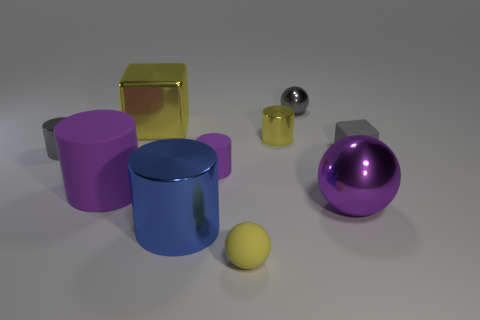Subtract all green spheres. How many purple cylinders are left? 2 Subtract all yellow spheres. How many spheres are left? 2 Subtract all balls. How many objects are left? 7 Subtract all yellow cylinders. How many cylinders are left? 4 Subtract 0 cyan cubes. How many objects are left? 10 Subtract 2 cylinders. How many cylinders are left? 3 Subtract all blue cubes. Subtract all green spheres. How many cubes are left? 2 Subtract all large yellow blocks. Subtract all big brown rubber blocks. How many objects are left? 9 Add 5 tiny yellow rubber things. How many tiny yellow rubber things are left? 6 Add 6 small yellow shiny balls. How many small yellow shiny balls exist? 6 